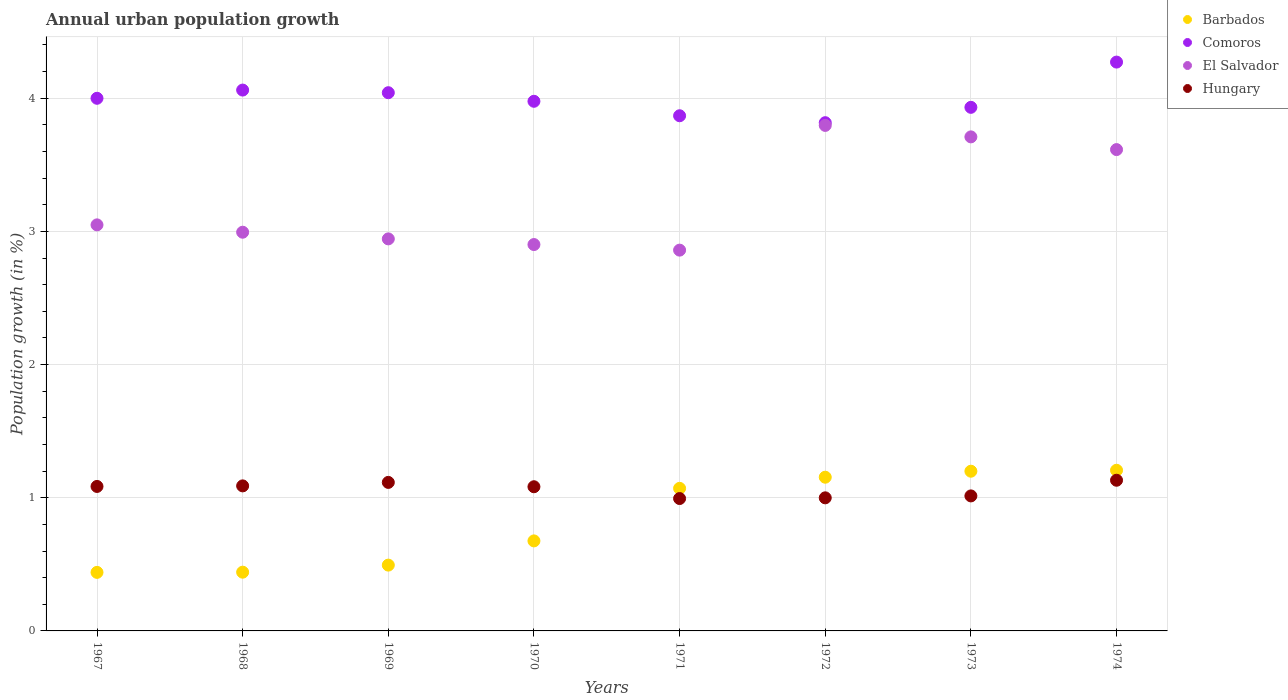How many different coloured dotlines are there?
Make the answer very short. 4. What is the percentage of urban population growth in Hungary in 1973?
Your answer should be compact. 1.01. Across all years, what is the maximum percentage of urban population growth in Barbados?
Your answer should be compact. 1.21. Across all years, what is the minimum percentage of urban population growth in Barbados?
Offer a terse response. 0.44. In which year was the percentage of urban population growth in Hungary maximum?
Offer a very short reply. 1974. In which year was the percentage of urban population growth in El Salvador minimum?
Offer a very short reply. 1971. What is the total percentage of urban population growth in Barbados in the graph?
Your answer should be very brief. 6.68. What is the difference between the percentage of urban population growth in El Salvador in 1968 and that in 1973?
Keep it short and to the point. -0.72. What is the difference between the percentage of urban population growth in Hungary in 1971 and the percentage of urban population growth in El Salvador in 1974?
Provide a succinct answer. -2.62. What is the average percentage of urban population growth in Comoros per year?
Provide a succinct answer. 4. In the year 1967, what is the difference between the percentage of urban population growth in Barbados and percentage of urban population growth in Comoros?
Keep it short and to the point. -3.56. In how many years, is the percentage of urban population growth in Barbados greater than 2.4 %?
Your response must be concise. 0. What is the ratio of the percentage of urban population growth in Hungary in 1967 to that in 1974?
Your answer should be compact. 0.96. Is the percentage of urban population growth in El Salvador in 1969 less than that in 1974?
Make the answer very short. Yes. Is the difference between the percentage of urban population growth in Barbados in 1969 and 1973 greater than the difference between the percentage of urban population growth in Comoros in 1969 and 1973?
Your answer should be very brief. No. What is the difference between the highest and the second highest percentage of urban population growth in Barbados?
Make the answer very short. 0.01. What is the difference between the highest and the lowest percentage of urban population growth in Barbados?
Give a very brief answer. 0.77. Does the percentage of urban population growth in Barbados monotonically increase over the years?
Your answer should be very brief. Yes. Is the percentage of urban population growth in Comoros strictly greater than the percentage of urban population growth in Barbados over the years?
Offer a very short reply. Yes. How many dotlines are there?
Your answer should be very brief. 4. What is the difference between two consecutive major ticks on the Y-axis?
Provide a short and direct response. 1. Are the values on the major ticks of Y-axis written in scientific E-notation?
Provide a succinct answer. No. Does the graph contain grids?
Provide a succinct answer. Yes. Where does the legend appear in the graph?
Keep it short and to the point. Top right. How are the legend labels stacked?
Your response must be concise. Vertical. What is the title of the graph?
Your response must be concise. Annual urban population growth. What is the label or title of the Y-axis?
Your response must be concise. Population growth (in %). What is the Population growth (in %) of Barbados in 1967?
Your answer should be compact. 0.44. What is the Population growth (in %) of Comoros in 1967?
Make the answer very short. 4. What is the Population growth (in %) of El Salvador in 1967?
Ensure brevity in your answer.  3.05. What is the Population growth (in %) in Hungary in 1967?
Your answer should be very brief. 1.08. What is the Population growth (in %) in Barbados in 1968?
Your response must be concise. 0.44. What is the Population growth (in %) of Comoros in 1968?
Give a very brief answer. 4.06. What is the Population growth (in %) of El Salvador in 1968?
Make the answer very short. 2.99. What is the Population growth (in %) in Hungary in 1968?
Your answer should be very brief. 1.09. What is the Population growth (in %) in Barbados in 1969?
Make the answer very short. 0.49. What is the Population growth (in %) of Comoros in 1969?
Offer a terse response. 4.04. What is the Population growth (in %) of El Salvador in 1969?
Offer a terse response. 2.94. What is the Population growth (in %) in Hungary in 1969?
Your answer should be compact. 1.12. What is the Population growth (in %) in Barbados in 1970?
Offer a very short reply. 0.68. What is the Population growth (in %) of Comoros in 1970?
Give a very brief answer. 3.98. What is the Population growth (in %) in El Salvador in 1970?
Provide a short and direct response. 2.9. What is the Population growth (in %) of Hungary in 1970?
Make the answer very short. 1.08. What is the Population growth (in %) in Barbados in 1971?
Provide a succinct answer. 1.07. What is the Population growth (in %) in Comoros in 1971?
Your answer should be very brief. 3.87. What is the Population growth (in %) of El Salvador in 1971?
Offer a very short reply. 2.86. What is the Population growth (in %) of Hungary in 1971?
Your answer should be compact. 0.99. What is the Population growth (in %) in Barbados in 1972?
Make the answer very short. 1.15. What is the Population growth (in %) of Comoros in 1972?
Offer a very short reply. 3.82. What is the Population growth (in %) of El Salvador in 1972?
Provide a short and direct response. 3.8. What is the Population growth (in %) in Hungary in 1972?
Offer a terse response. 1. What is the Population growth (in %) in Barbados in 1973?
Keep it short and to the point. 1.2. What is the Population growth (in %) of Comoros in 1973?
Offer a terse response. 3.93. What is the Population growth (in %) in El Salvador in 1973?
Your answer should be compact. 3.71. What is the Population growth (in %) in Hungary in 1973?
Offer a terse response. 1.01. What is the Population growth (in %) of Barbados in 1974?
Make the answer very short. 1.21. What is the Population growth (in %) of Comoros in 1974?
Give a very brief answer. 4.27. What is the Population growth (in %) in El Salvador in 1974?
Keep it short and to the point. 3.61. What is the Population growth (in %) of Hungary in 1974?
Keep it short and to the point. 1.13. Across all years, what is the maximum Population growth (in %) of Barbados?
Offer a very short reply. 1.21. Across all years, what is the maximum Population growth (in %) of Comoros?
Ensure brevity in your answer.  4.27. Across all years, what is the maximum Population growth (in %) in El Salvador?
Provide a succinct answer. 3.8. Across all years, what is the maximum Population growth (in %) in Hungary?
Offer a terse response. 1.13. Across all years, what is the minimum Population growth (in %) in Barbados?
Ensure brevity in your answer.  0.44. Across all years, what is the minimum Population growth (in %) in Comoros?
Offer a very short reply. 3.82. Across all years, what is the minimum Population growth (in %) of El Salvador?
Offer a very short reply. 2.86. Across all years, what is the minimum Population growth (in %) in Hungary?
Provide a short and direct response. 0.99. What is the total Population growth (in %) in Barbados in the graph?
Provide a short and direct response. 6.68. What is the total Population growth (in %) of Comoros in the graph?
Your answer should be very brief. 31.97. What is the total Population growth (in %) in El Salvador in the graph?
Provide a short and direct response. 25.87. What is the total Population growth (in %) in Hungary in the graph?
Give a very brief answer. 8.51. What is the difference between the Population growth (in %) of Barbados in 1967 and that in 1968?
Make the answer very short. -0. What is the difference between the Population growth (in %) of Comoros in 1967 and that in 1968?
Make the answer very short. -0.06. What is the difference between the Population growth (in %) in El Salvador in 1967 and that in 1968?
Make the answer very short. 0.06. What is the difference between the Population growth (in %) in Hungary in 1967 and that in 1968?
Provide a succinct answer. -0. What is the difference between the Population growth (in %) of Barbados in 1967 and that in 1969?
Give a very brief answer. -0.05. What is the difference between the Population growth (in %) of Comoros in 1967 and that in 1969?
Keep it short and to the point. -0.04. What is the difference between the Population growth (in %) in El Salvador in 1967 and that in 1969?
Provide a short and direct response. 0.11. What is the difference between the Population growth (in %) in Hungary in 1967 and that in 1969?
Provide a succinct answer. -0.03. What is the difference between the Population growth (in %) in Barbados in 1967 and that in 1970?
Offer a very short reply. -0.24. What is the difference between the Population growth (in %) of Comoros in 1967 and that in 1970?
Your response must be concise. 0.02. What is the difference between the Population growth (in %) in El Salvador in 1967 and that in 1970?
Offer a terse response. 0.15. What is the difference between the Population growth (in %) in Hungary in 1967 and that in 1970?
Provide a short and direct response. 0. What is the difference between the Population growth (in %) in Barbados in 1967 and that in 1971?
Provide a short and direct response. -0.63. What is the difference between the Population growth (in %) in Comoros in 1967 and that in 1971?
Provide a short and direct response. 0.13. What is the difference between the Population growth (in %) of El Salvador in 1967 and that in 1971?
Provide a short and direct response. 0.19. What is the difference between the Population growth (in %) of Hungary in 1967 and that in 1971?
Ensure brevity in your answer.  0.09. What is the difference between the Population growth (in %) of Barbados in 1967 and that in 1972?
Give a very brief answer. -0.71. What is the difference between the Population growth (in %) in Comoros in 1967 and that in 1972?
Your answer should be very brief. 0.18. What is the difference between the Population growth (in %) in El Salvador in 1967 and that in 1972?
Your answer should be very brief. -0.75. What is the difference between the Population growth (in %) in Hungary in 1967 and that in 1972?
Offer a very short reply. 0.09. What is the difference between the Population growth (in %) of Barbados in 1967 and that in 1973?
Keep it short and to the point. -0.76. What is the difference between the Population growth (in %) in Comoros in 1967 and that in 1973?
Your answer should be compact. 0.07. What is the difference between the Population growth (in %) in El Salvador in 1967 and that in 1973?
Offer a terse response. -0.66. What is the difference between the Population growth (in %) of Hungary in 1967 and that in 1973?
Make the answer very short. 0.07. What is the difference between the Population growth (in %) in Barbados in 1967 and that in 1974?
Give a very brief answer. -0.77. What is the difference between the Population growth (in %) of Comoros in 1967 and that in 1974?
Make the answer very short. -0.27. What is the difference between the Population growth (in %) in El Salvador in 1967 and that in 1974?
Your answer should be very brief. -0.57. What is the difference between the Population growth (in %) in Hungary in 1967 and that in 1974?
Provide a short and direct response. -0.05. What is the difference between the Population growth (in %) of Barbados in 1968 and that in 1969?
Your answer should be compact. -0.05. What is the difference between the Population growth (in %) of Comoros in 1968 and that in 1969?
Your answer should be very brief. 0.02. What is the difference between the Population growth (in %) in El Salvador in 1968 and that in 1969?
Make the answer very short. 0.05. What is the difference between the Population growth (in %) in Hungary in 1968 and that in 1969?
Offer a terse response. -0.03. What is the difference between the Population growth (in %) in Barbados in 1968 and that in 1970?
Your answer should be very brief. -0.23. What is the difference between the Population growth (in %) in Comoros in 1968 and that in 1970?
Keep it short and to the point. 0.08. What is the difference between the Population growth (in %) of El Salvador in 1968 and that in 1970?
Provide a short and direct response. 0.09. What is the difference between the Population growth (in %) in Hungary in 1968 and that in 1970?
Provide a succinct answer. 0.01. What is the difference between the Population growth (in %) of Barbados in 1968 and that in 1971?
Provide a short and direct response. -0.63. What is the difference between the Population growth (in %) of Comoros in 1968 and that in 1971?
Keep it short and to the point. 0.19. What is the difference between the Population growth (in %) in El Salvador in 1968 and that in 1971?
Offer a very short reply. 0.13. What is the difference between the Population growth (in %) in Hungary in 1968 and that in 1971?
Provide a short and direct response. 0.1. What is the difference between the Population growth (in %) of Barbados in 1968 and that in 1972?
Your answer should be compact. -0.71. What is the difference between the Population growth (in %) of Comoros in 1968 and that in 1972?
Keep it short and to the point. 0.24. What is the difference between the Population growth (in %) in El Salvador in 1968 and that in 1972?
Provide a short and direct response. -0.8. What is the difference between the Population growth (in %) of Hungary in 1968 and that in 1972?
Provide a short and direct response. 0.09. What is the difference between the Population growth (in %) in Barbados in 1968 and that in 1973?
Your answer should be very brief. -0.76. What is the difference between the Population growth (in %) in Comoros in 1968 and that in 1973?
Make the answer very short. 0.13. What is the difference between the Population growth (in %) of El Salvador in 1968 and that in 1973?
Give a very brief answer. -0.72. What is the difference between the Population growth (in %) in Hungary in 1968 and that in 1973?
Make the answer very short. 0.08. What is the difference between the Population growth (in %) of Barbados in 1968 and that in 1974?
Your response must be concise. -0.77. What is the difference between the Population growth (in %) in Comoros in 1968 and that in 1974?
Provide a short and direct response. -0.21. What is the difference between the Population growth (in %) of El Salvador in 1968 and that in 1974?
Keep it short and to the point. -0.62. What is the difference between the Population growth (in %) of Hungary in 1968 and that in 1974?
Ensure brevity in your answer.  -0.04. What is the difference between the Population growth (in %) in Barbados in 1969 and that in 1970?
Your answer should be compact. -0.18. What is the difference between the Population growth (in %) of Comoros in 1969 and that in 1970?
Provide a succinct answer. 0.06. What is the difference between the Population growth (in %) in El Salvador in 1969 and that in 1970?
Offer a terse response. 0.04. What is the difference between the Population growth (in %) in Hungary in 1969 and that in 1970?
Ensure brevity in your answer.  0.03. What is the difference between the Population growth (in %) in Barbados in 1969 and that in 1971?
Provide a succinct answer. -0.58. What is the difference between the Population growth (in %) of Comoros in 1969 and that in 1971?
Ensure brevity in your answer.  0.17. What is the difference between the Population growth (in %) in El Salvador in 1969 and that in 1971?
Your answer should be compact. 0.08. What is the difference between the Population growth (in %) in Hungary in 1969 and that in 1971?
Give a very brief answer. 0.12. What is the difference between the Population growth (in %) in Barbados in 1969 and that in 1972?
Offer a very short reply. -0.66. What is the difference between the Population growth (in %) in Comoros in 1969 and that in 1972?
Your answer should be very brief. 0.23. What is the difference between the Population growth (in %) in El Salvador in 1969 and that in 1972?
Offer a very short reply. -0.85. What is the difference between the Population growth (in %) in Hungary in 1969 and that in 1972?
Keep it short and to the point. 0.12. What is the difference between the Population growth (in %) of Barbados in 1969 and that in 1973?
Provide a short and direct response. -0.7. What is the difference between the Population growth (in %) of Comoros in 1969 and that in 1973?
Give a very brief answer. 0.11. What is the difference between the Population growth (in %) of El Salvador in 1969 and that in 1973?
Your answer should be very brief. -0.77. What is the difference between the Population growth (in %) of Hungary in 1969 and that in 1973?
Your response must be concise. 0.1. What is the difference between the Population growth (in %) of Barbados in 1969 and that in 1974?
Give a very brief answer. -0.71. What is the difference between the Population growth (in %) of Comoros in 1969 and that in 1974?
Offer a very short reply. -0.23. What is the difference between the Population growth (in %) of El Salvador in 1969 and that in 1974?
Your answer should be very brief. -0.67. What is the difference between the Population growth (in %) of Hungary in 1969 and that in 1974?
Keep it short and to the point. -0.02. What is the difference between the Population growth (in %) of Barbados in 1970 and that in 1971?
Provide a succinct answer. -0.39. What is the difference between the Population growth (in %) in Comoros in 1970 and that in 1971?
Offer a very short reply. 0.11. What is the difference between the Population growth (in %) in El Salvador in 1970 and that in 1971?
Provide a short and direct response. 0.04. What is the difference between the Population growth (in %) of Hungary in 1970 and that in 1971?
Offer a very short reply. 0.09. What is the difference between the Population growth (in %) of Barbados in 1970 and that in 1972?
Provide a succinct answer. -0.48. What is the difference between the Population growth (in %) of Comoros in 1970 and that in 1972?
Offer a terse response. 0.16. What is the difference between the Population growth (in %) in El Salvador in 1970 and that in 1972?
Give a very brief answer. -0.89. What is the difference between the Population growth (in %) in Hungary in 1970 and that in 1972?
Your answer should be very brief. 0.08. What is the difference between the Population growth (in %) in Barbados in 1970 and that in 1973?
Your response must be concise. -0.52. What is the difference between the Population growth (in %) of Comoros in 1970 and that in 1973?
Offer a very short reply. 0.05. What is the difference between the Population growth (in %) of El Salvador in 1970 and that in 1973?
Your response must be concise. -0.81. What is the difference between the Population growth (in %) in Hungary in 1970 and that in 1973?
Give a very brief answer. 0.07. What is the difference between the Population growth (in %) of Barbados in 1970 and that in 1974?
Offer a terse response. -0.53. What is the difference between the Population growth (in %) of Comoros in 1970 and that in 1974?
Give a very brief answer. -0.29. What is the difference between the Population growth (in %) in El Salvador in 1970 and that in 1974?
Offer a very short reply. -0.71. What is the difference between the Population growth (in %) in Hungary in 1970 and that in 1974?
Make the answer very short. -0.05. What is the difference between the Population growth (in %) of Barbados in 1971 and that in 1972?
Offer a terse response. -0.08. What is the difference between the Population growth (in %) in Comoros in 1971 and that in 1972?
Ensure brevity in your answer.  0.05. What is the difference between the Population growth (in %) of El Salvador in 1971 and that in 1972?
Give a very brief answer. -0.94. What is the difference between the Population growth (in %) of Hungary in 1971 and that in 1972?
Offer a very short reply. -0.01. What is the difference between the Population growth (in %) of Barbados in 1971 and that in 1973?
Your answer should be very brief. -0.13. What is the difference between the Population growth (in %) in Comoros in 1971 and that in 1973?
Give a very brief answer. -0.06. What is the difference between the Population growth (in %) of El Salvador in 1971 and that in 1973?
Give a very brief answer. -0.85. What is the difference between the Population growth (in %) of Hungary in 1971 and that in 1973?
Make the answer very short. -0.02. What is the difference between the Population growth (in %) in Barbados in 1971 and that in 1974?
Ensure brevity in your answer.  -0.14. What is the difference between the Population growth (in %) of Comoros in 1971 and that in 1974?
Your answer should be compact. -0.4. What is the difference between the Population growth (in %) in El Salvador in 1971 and that in 1974?
Make the answer very short. -0.76. What is the difference between the Population growth (in %) in Hungary in 1971 and that in 1974?
Your answer should be very brief. -0.14. What is the difference between the Population growth (in %) in Barbados in 1972 and that in 1973?
Your response must be concise. -0.04. What is the difference between the Population growth (in %) of Comoros in 1972 and that in 1973?
Keep it short and to the point. -0.12. What is the difference between the Population growth (in %) in El Salvador in 1972 and that in 1973?
Your answer should be compact. 0.09. What is the difference between the Population growth (in %) of Hungary in 1972 and that in 1973?
Provide a short and direct response. -0.01. What is the difference between the Population growth (in %) in Barbados in 1972 and that in 1974?
Give a very brief answer. -0.05. What is the difference between the Population growth (in %) of Comoros in 1972 and that in 1974?
Provide a short and direct response. -0.46. What is the difference between the Population growth (in %) of El Salvador in 1972 and that in 1974?
Keep it short and to the point. 0.18. What is the difference between the Population growth (in %) of Hungary in 1972 and that in 1974?
Make the answer very short. -0.13. What is the difference between the Population growth (in %) in Barbados in 1973 and that in 1974?
Provide a succinct answer. -0.01. What is the difference between the Population growth (in %) of Comoros in 1973 and that in 1974?
Your answer should be compact. -0.34. What is the difference between the Population growth (in %) in El Salvador in 1973 and that in 1974?
Offer a very short reply. 0.1. What is the difference between the Population growth (in %) of Hungary in 1973 and that in 1974?
Your response must be concise. -0.12. What is the difference between the Population growth (in %) of Barbados in 1967 and the Population growth (in %) of Comoros in 1968?
Your response must be concise. -3.62. What is the difference between the Population growth (in %) in Barbados in 1967 and the Population growth (in %) in El Salvador in 1968?
Ensure brevity in your answer.  -2.55. What is the difference between the Population growth (in %) in Barbados in 1967 and the Population growth (in %) in Hungary in 1968?
Your answer should be very brief. -0.65. What is the difference between the Population growth (in %) in Comoros in 1967 and the Population growth (in %) in Hungary in 1968?
Give a very brief answer. 2.91. What is the difference between the Population growth (in %) in El Salvador in 1967 and the Population growth (in %) in Hungary in 1968?
Provide a succinct answer. 1.96. What is the difference between the Population growth (in %) of Barbados in 1967 and the Population growth (in %) of Comoros in 1969?
Offer a very short reply. -3.6. What is the difference between the Population growth (in %) in Barbados in 1967 and the Population growth (in %) in El Salvador in 1969?
Keep it short and to the point. -2.5. What is the difference between the Population growth (in %) of Barbados in 1967 and the Population growth (in %) of Hungary in 1969?
Provide a short and direct response. -0.68. What is the difference between the Population growth (in %) in Comoros in 1967 and the Population growth (in %) in El Salvador in 1969?
Offer a terse response. 1.06. What is the difference between the Population growth (in %) of Comoros in 1967 and the Population growth (in %) of Hungary in 1969?
Your answer should be compact. 2.88. What is the difference between the Population growth (in %) of El Salvador in 1967 and the Population growth (in %) of Hungary in 1969?
Offer a terse response. 1.93. What is the difference between the Population growth (in %) in Barbados in 1967 and the Population growth (in %) in Comoros in 1970?
Offer a very short reply. -3.54. What is the difference between the Population growth (in %) of Barbados in 1967 and the Population growth (in %) of El Salvador in 1970?
Keep it short and to the point. -2.46. What is the difference between the Population growth (in %) of Barbados in 1967 and the Population growth (in %) of Hungary in 1970?
Offer a terse response. -0.64. What is the difference between the Population growth (in %) of Comoros in 1967 and the Population growth (in %) of El Salvador in 1970?
Your response must be concise. 1.1. What is the difference between the Population growth (in %) of Comoros in 1967 and the Population growth (in %) of Hungary in 1970?
Your answer should be very brief. 2.92. What is the difference between the Population growth (in %) of El Salvador in 1967 and the Population growth (in %) of Hungary in 1970?
Your answer should be very brief. 1.97. What is the difference between the Population growth (in %) of Barbados in 1967 and the Population growth (in %) of Comoros in 1971?
Make the answer very short. -3.43. What is the difference between the Population growth (in %) in Barbados in 1967 and the Population growth (in %) in El Salvador in 1971?
Ensure brevity in your answer.  -2.42. What is the difference between the Population growth (in %) of Barbados in 1967 and the Population growth (in %) of Hungary in 1971?
Keep it short and to the point. -0.55. What is the difference between the Population growth (in %) in Comoros in 1967 and the Population growth (in %) in El Salvador in 1971?
Your answer should be compact. 1.14. What is the difference between the Population growth (in %) in Comoros in 1967 and the Population growth (in %) in Hungary in 1971?
Offer a terse response. 3.01. What is the difference between the Population growth (in %) in El Salvador in 1967 and the Population growth (in %) in Hungary in 1971?
Make the answer very short. 2.05. What is the difference between the Population growth (in %) of Barbados in 1967 and the Population growth (in %) of Comoros in 1972?
Offer a terse response. -3.38. What is the difference between the Population growth (in %) in Barbados in 1967 and the Population growth (in %) in El Salvador in 1972?
Provide a short and direct response. -3.36. What is the difference between the Population growth (in %) in Barbados in 1967 and the Population growth (in %) in Hungary in 1972?
Offer a terse response. -0.56. What is the difference between the Population growth (in %) in Comoros in 1967 and the Population growth (in %) in El Salvador in 1972?
Your answer should be compact. 0.2. What is the difference between the Population growth (in %) of Comoros in 1967 and the Population growth (in %) of Hungary in 1972?
Offer a very short reply. 3. What is the difference between the Population growth (in %) in El Salvador in 1967 and the Population growth (in %) in Hungary in 1972?
Offer a terse response. 2.05. What is the difference between the Population growth (in %) of Barbados in 1967 and the Population growth (in %) of Comoros in 1973?
Ensure brevity in your answer.  -3.49. What is the difference between the Population growth (in %) in Barbados in 1967 and the Population growth (in %) in El Salvador in 1973?
Keep it short and to the point. -3.27. What is the difference between the Population growth (in %) of Barbados in 1967 and the Population growth (in %) of Hungary in 1973?
Your response must be concise. -0.57. What is the difference between the Population growth (in %) in Comoros in 1967 and the Population growth (in %) in El Salvador in 1973?
Offer a terse response. 0.29. What is the difference between the Population growth (in %) in Comoros in 1967 and the Population growth (in %) in Hungary in 1973?
Your answer should be very brief. 2.99. What is the difference between the Population growth (in %) in El Salvador in 1967 and the Population growth (in %) in Hungary in 1973?
Offer a terse response. 2.04. What is the difference between the Population growth (in %) of Barbados in 1967 and the Population growth (in %) of Comoros in 1974?
Your answer should be very brief. -3.83. What is the difference between the Population growth (in %) in Barbados in 1967 and the Population growth (in %) in El Salvador in 1974?
Make the answer very short. -3.17. What is the difference between the Population growth (in %) in Barbados in 1967 and the Population growth (in %) in Hungary in 1974?
Your answer should be very brief. -0.69. What is the difference between the Population growth (in %) of Comoros in 1967 and the Population growth (in %) of El Salvador in 1974?
Provide a short and direct response. 0.39. What is the difference between the Population growth (in %) of Comoros in 1967 and the Population growth (in %) of Hungary in 1974?
Your answer should be compact. 2.87. What is the difference between the Population growth (in %) in El Salvador in 1967 and the Population growth (in %) in Hungary in 1974?
Give a very brief answer. 1.92. What is the difference between the Population growth (in %) of Barbados in 1968 and the Population growth (in %) of Comoros in 1969?
Provide a short and direct response. -3.6. What is the difference between the Population growth (in %) in Barbados in 1968 and the Population growth (in %) in El Salvador in 1969?
Make the answer very short. -2.5. What is the difference between the Population growth (in %) in Barbados in 1968 and the Population growth (in %) in Hungary in 1969?
Provide a succinct answer. -0.67. What is the difference between the Population growth (in %) of Comoros in 1968 and the Population growth (in %) of El Salvador in 1969?
Provide a succinct answer. 1.12. What is the difference between the Population growth (in %) of Comoros in 1968 and the Population growth (in %) of Hungary in 1969?
Provide a succinct answer. 2.95. What is the difference between the Population growth (in %) of El Salvador in 1968 and the Population growth (in %) of Hungary in 1969?
Give a very brief answer. 1.88. What is the difference between the Population growth (in %) in Barbados in 1968 and the Population growth (in %) in Comoros in 1970?
Give a very brief answer. -3.54. What is the difference between the Population growth (in %) in Barbados in 1968 and the Population growth (in %) in El Salvador in 1970?
Offer a terse response. -2.46. What is the difference between the Population growth (in %) in Barbados in 1968 and the Population growth (in %) in Hungary in 1970?
Provide a succinct answer. -0.64. What is the difference between the Population growth (in %) in Comoros in 1968 and the Population growth (in %) in El Salvador in 1970?
Make the answer very short. 1.16. What is the difference between the Population growth (in %) of Comoros in 1968 and the Population growth (in %) of Hungary in 1970?
Give a very brief answer. 2.98. What is the difference between the Population growth (in %) in El Salvador in 1968 and the Population growth (in %) in Hungary in 1970?
Offer a terse response. 1.91. What is the difference between the Population growth (in %) in Barbados in 1968 and the Population growth (in %) in Comoros in 1971?
Offer a very short reply. -3.43. What is the difference between the Population growth (in %) in Barbados in 1968 and the Population growth (in %) in El Salvador in 1971?
Offer a very short reply. -2.42. What is the difference between the Population growth (in %) in Barbados in 1968 and the Population growth (in %) in Hungary in 1971?
Your response must be concise. -0.55. What is the difference between the Population growth (in %) in Comoros in 1968 and the Population growth (in %) in El Salvador in 1971?
Give a very brief answer. 1.2. What is the difference between the Population growth (in %) of Comoros in 1968 and the Population growth (in %) of Hungary in 1971?
Provide a succinct answer. 3.07. What is the difference between the Population growth (in %) in El Salvador in 1968 and the Population growth (in %) in Hungary in 1971?
Your answer should be compact. 2. What is the difference between the Population growth (in %) in Barbados in 1968 and the Population growth (in %) in Comoros in 1972?
Keep it short and to the point. -3.38. What is the difference between the Population growth (in %) of Barbados in 1968 and the Population growth (in %) of El Salvador in 1972?
Ensure brevity in your answer.  -3.35. What is the difference between the Population growth (in %) in Barbados in 1968 and the Population growth (in %) in Hungary in 1972?
Your response must be concise. -0.56. What is the difference between the Population growth (in %) of Comoros in 1968 and the Population growth (in %) of El Salvador in 1972?
Provide a short and direct response. 0.27. What is the difference between the Population growth (in %) of Comoros in 1968 and the Population growth (in %) of Hungary in 1972?
Make the answer very short. 3.06. What is the difference between the Population growth (in %) in El Salvador in 1968 and the Population growth (in %) in Hungary in 1972?
Offer a very short reply. 1.99. What is the difference between the Population growth (in %) of Barbados in 1968 and the Population growth (in %) of Comoros in 1973?
Offer a terse response. -3.49. What is the difference between the Population growth (in %) in Barbados in 1968 and the Population growth (in %) in El Salvador in 1973?
Your answer should be compact. -3.27. What is the difference between the Population growth (in %) in Barbados in 1968 and the Population growth (in %) in Hungary in 1973?
Make the answer very short. -0.57. What is the difference between the Population growth (in %) in Comoros in 1968 and the Population growth (in %) in El Salvador in 1973?
Ensure brevity in your answer.  0.35. What is the difference between the Population growth (in %) of Comoros in 1968 and the Population growth (in %) of Hungary in 1973?
Offer a terse response. 3.05. What is the difference between the Population growth (in %) in El Salvador in 1968 and the Population growth (in %) in Hungary in 1973?
Give a very brief answer. 1.98. What is the difference between the Population growth (in %) in Barbados in 1968 and the Population growth (in %) in Comoros in 1974?
Offer a very short reply. -3.83. What is the difference between the Population growth (in %) in Barbados in 1968 and the Population growth (in %) in El Salvador in 1974?
Your answer should be very brief. -3.17. What is the difference between the Population growth (in %) of Barbados in 1968 and the Population growth (in %) of Hungary in 1974?
Your answer should be very brief. -0.69. What is the difference between the Population growth (in %) in Comoros in 1968 and the Population growth (in %) in El Salvador in 1974?
Offer a very short reply. 0.45. What is the difference between the Population growth (in %) in Comoros in 1968 and the Population growth (in %) in Hungary in 1974?
Offer a very short reply. 2.93. What is the difference between the Population growth (in %) of El Salvador in 1968 and the Population growth (in %) of Hungary in 1974?
Your answer should be very brief. 1.86. What is the difference between the Population growth (in %) of Barbados in 1969 and the Population growth (in %) of Comoros in 1970?
Give a very brief answer. -3.48. What is the difference between the Population growth (in %) in Barbados in 1969 and the Population growth (in %) in El Salvador in 1970?
Make the answer very short. -2.41. What is the difference between the Population growth (in %) of Barbados in 1969 and the Population growth (in %) of Hungary in 1970?
Provide a short and direct response. -0.59. What is the difference between the Population growth (in %) of Comoros in 1969 and the Population growth (in %) of El Salvador in 1970?
Make the answer very short. 1.14. What is the difference between the Population growth (in %) in Comoros in 1969 and the Population growth (in %) in Hungary in 1970?
Give a very brief answer. 2.96. What is the difference between the Population growth (in %) in El Salvador in 1969 and the Population growth (in %) in Hungary in 1970?
Keep it short and to the point. 1.86. What is the difference between the Population growth (in %) of Barbados in 1969 and the Population growth (in %) of Comoros in 1971?
Give a very brief answer. -3.37. What is the difference between the Population growth (in %) in Barbados in 1969 and the Population growth (in %) in El Salvador in 1971?
Provide a succinct answer. -2.37. What is the difference between the Population growth (in %) in Barbados in 1969 and the Population growth (in %) in Hungary in 1971?
Offer a very short reply. -0.5. What is the difference between the Population growth (in %) in Comoros in 1969 and the Population growth (in %) in El Salvador in 1971?
Provide a short and direct response. 1.18. What is the difference between the Population growth (in %) of Comoros in 1969 and the Population growth (in %) of Hungary in 1971?
Give a very brief answer. 3.05. What is the difference between the Population growth (in %) of El Salvador in 1969 and the Population growth (in %) of Hungary in 1971?
Offer a very short reply. 1.95. What is the difference between the Population growth (in %) of Barbados in 1969 and the Population growth (in %) of Comoros in 1972?
Provide a short and direct response. -3.32. What is the difference between the Population growth (in %) in Barbados in 1969 and the Population growth (in %) in El Salvador in 1972?
Ensure brevity in your answer.  -3.3. What is the difference between the Population growth (in %) in Barbados in 1969 and the Population growth (in %) in Hungary in 1972?
Ensure brevity in your answer.  -0.51. What is the difference between the Population growth (in %) in Comoros in 1969 and the Population growth (in %) in El Salvador in 1972?
Your answer should be compact. 0.25. What is the difference between the Population growth (in %) of Comoros in 1969 and the Population growth (in %) of Hungary in 1972?
Your answer should be compact. 3.04. What is the difference between the Population growth (in %) in El Salvador in 1969 and the Population growth (in %) in Hungary in 1972?
Offer a very short reply. 1.94. What is the difference between the Population growth (in %) in Barbados in 1969 and the Population growth (in %) in Comoros in 1973?
Provide a succinct answer. -3.44. What is the difference between the Population growth (in %) in Barbados in 1969 and the Population growth (in %) in El Salvador in 1973?
Provide a short and direct response. -3.22. What is the difference between the Population growth (in %) of Barbados in 1969 and the Population growth (in %) of Hungary in 1973?
Make the answer very short. -0.52. What is the difference between the Population growth (in %) of Comoros in 1969 and the Population growth (in %) of El Salvador in 1973?
Provide a succinct answer. 0.33. What is the difference between the Population growth (in %) in Comoros in 1969 and the Population growth (in %) in Hungary in 1973?
Give a very brief answer. 3.03. What is the difference between the Population growth (in %) in El Salvador in 1969 and the Population growth (in %) in Hungary in 1973?
Your answer should be very brief. 1.93. What is the difference between the Population growth (in %) of Barbados in 1969 and the Population growth (in %) of Comoros in 1974?
Provide a short and direct response. -3.78. What is the difference between the Population growth (in %) in Barbados in 1969 and the Population growth (in %) in El Salvador in 1974?
Give a very brief answer. -3.12. What is the difference between the Population growth (in %) of Barbados in 1969 and the Population growth (in %) of Hungary in 1974?
Make the answer very short. -0.64. What is the difference between the Population growth (in %) in Comoros in 1969 and the Population growth (in %) in El Salvador in 1974?
Make the answer very short. 0.43. What is the difference between the Population growth (in %) of Comoros in 1969 and the Population growth (in %) of Hungary in 1974?
Offer a very short reply. 2.91. What is the difference between the Population growth (in %) in El Salvador in 1969 and the Population growth (in %) in Hungary in 1974?
Your response must be concise. 1.81. What is the difference between the Population growth (in %) in Barbados in 1970 and the Population growth (in %) in Comoros in 1971?
Keep it short and to the point. -3.19. What is the difference between the Population growth (in %) in Barbados in 1970 and the Population growth (in %) in El Salvador in 1971?
Your response must be concise. -2.18. What is the difference between the Population growth (in %) in Barbados in 1970 and the Population growth (in %) in Hungary in 1971?
Your answer should be very brief. -0.32. What is the difference between the Population growth (in %) in Comoros in 1970 and the Population growth (in %) in El Salvador in 1971?
Offer a terse response. 1.12. What is the difference between the Population growth (in %) of Comoros in 1970 and the Population growth (in %) of Hungary in 1971?
Ensure brevity in your answer.  2.98. What is the difference between the Population growth (in %) in El Salvador in 1970 and the Population growth (in %) in Hungary in 1971?
Your answer should be compact. 1.91. What is the difference between the Population growth (in %) in Barbados in 1970 and the Population growth (in %) in Comoros in 1972?
Ensure brevity in your answer.  -3.14. What is the difference between the Population growth (in %) of Barbados in 1970 and the Population growth (in %) of El Salvador in 1972?
Your response must be concise. -3.12. What is the difference between the Population growth (in %) of Barbados in 1970 and the Population growth (in %) of Hungary in 1972?
Your response must be concise. -0.32. What is the difference between the Population growth (in %) of Comoros in 1970 and the Population growth (in %) of El Salvador in 1972?
Make the answer very short. 0.18. What is the difference between the Population growth (in %) in Comoros in 1970 and the Population growth (in %) in Hungary in 1972?
Give a very brief answer. 2.98. What is the difference between the Population growth (in %) in El Salvador in 1970 and the Population growth (in %) in Hungary in 1972?
Your answer should be compact. 1.9. What is the difference between the Population growth (in %) in Barbados in 1970 and the Population growth (in %) in Comoros in 1973?
Provide a succinct answer. -3.26. What is the difference between the Population growth (in %) in Barbados in 1970 and the Population growth (in %) in El Salvador in 1973?
Make the answer very short. -3.03. What is the difference between the Population growth (in %) of Barbados in 1970 and the Population growth (in %) of Hungary in 1973?
Offer a terse response. -0.34. What is the difference between the Population growth (in %) of Comoros in 1970 and the Population growth (in %) of El Salvador in 1973?
Your answer should be very brief. 0.27. What is the difference between the Population growth (in %) of Comoros in 1970 and the Population growth (in %) of Hungary in 1973?
Your answer should be very brief. 2.96. What is the difference between the Population growth (in %) in El Salvador in 1970 and the Population growth (in %) in Hungary in 1973?
Offer a very short reply. 1.89. What is the difference between the Population growth (in %) of Barbados in 1970 and the Population growth (in %) of Comoros in 1974?
Provide a short and direct response. -3.6. What is the difference between the Population growth (in %) of Barbados in 1970 and the Population growth (in %) of El Salvador in 1974?
Ensure brevity in your answer.  -2.94. What is the difference between the Population growth (in %) of Barbados in 1970 and the Population growth (in %) of Hungary in 1974?
Make the answer very short. -0.46. What is the difference between the Population growth (in %) of Comoros in 1970 and the Population growth (in %) of El Salvador in 1974?
Offer a terse response. 0.36. What is the difference between the Population growth (in %) in Comoros in 1970 and the Population growth (in %) in Hungary in 1974?
Your response must be concise. 2.85. What is the difference between the Population growth (in %) of El Salvador in 1970 and the Population growth (in %) of Hungary in 1974?
Your answer should be very brief. 1.77. What is the difference between the Population growth (in %) of Barbados in 1971 and the Population growth (in %) of Comoros in 1972?
Your answer should be very brief. -2.75. What is the difference between the Population growth (in %) in Barbados in 1971 and the Population growth (in %) in El Salvador in 1972?
Keep it short and to the point. -2.73. What is the difference between the Population growth (in %) of Barbados in 1971 and the Population growth (in %) of Hungary in 1972?
Ensure brevity in your answer.  0.07. What is the difference between the Population growth (in %) in Comoros in 1971 and the Population growth (in %) in El Salvador in 1972?
Give a very brief answer. 0.07. What is the difference between the Population growth (in %) of Comoros in 1971 and the Population growth (in %) of Hungary in 1972?
Offer a very short reply. 2.87. What is the difference between the Population growth (in %) of El Salvador in 1971 and the Population growth (in %) of Hungary in 1972?
Keep it short and to the point. 1.86. What is the difference between the Population growth (in %) of Barbados in 1971 and the Population growth (in %) of Comoros in 1973?
Provide a short and direct response. -2.86. What is the difference between the Population growth (in %) of Barbados in 1971 and the Population growth (in %) of El Salvador in 1973?
Your answer should be very brief. -2.64. What is the difference between the Population growth (in %) in Barbados in 1971 and the Population growth (in %) in Hungary in 1973?
Keep it short and to the point. 0.06. What is the difference between the Population growth (in %) of Comoros in 1971 and the Population growth (in %) of El Salvador in 1973?
Your answer should be very brief. 0.16. What is the difference between the Population growth (in %) in Comoros in 1971 and the Population growth (in %) in Hungary in 1973?
Offer a very short reply. 2.85. What is the difference between the Population growth (in %) of El Salvador in 1971 and the Population growth (in %) of Hungary in 1973?
Your answer should be very brief. 1.85. What is the difference between the Population growth (in %) in Barbados in 1971 and the Population growth (in %) in Comoros in 1974?
Offer a very short reply. -3.2. What is the difference between the Population growth (in %) in Barbados in 1971 and the Population growth (in %) in El Salvador in 1974?
Keep it short and to the point. -2.54. What is the difference between the Population growth (in %) of Barbados in 1971 and the Population growth (in %) of Hungary in 1974?
Your answer should be very brief. -0.06. What is the difference between the Population growth (in %) of Comoros in 1971 and the Population growth (in %) of El Salvador in 1974?
Provide a succinct answer. 0.25. What is the difference between the Population growth (in %) in Comoros in 1971 and the Population growth (in %) in Hungary in 1974?
Make the answer very short. 2.74. What is the difference between the Population growth (in %) of El Salvador in 1971 and the Population growth (in %) of Hungary in 1974?
Offer a very short reply. 1.73. What is the difference between the Population growth (in %) of Barbados in 1972 and the Population growth (in %) of Comoros in 1973?
Your answer should be compact. -2.78. What is the difference between the Population growth (in %) of Barbados in 1972 and the Population growth (in %) of El Salvador in 1973?
Offer a very short reply. -2.56. What is the difference between the Population growth (in %) of Barbados in 1972 and the Population growth (in %) of Hungary in 1973?
Offer a very short reply. 0.14. What is the difference between the Population growth (in %) in Comoros in 1972 and the Population growth (in %) in El Salvador in 1973?
Make the answer very short. 0.11. What is the difference between the Population growth (in %) in Comoros in 1972 and the Population growth (in %) in Hungary in 1973?
Make the answer very short. 2.8. What is the difference between the Population growth (in %) of El Salvador in 1972 and the Population growth (in %) of Hungary in 1973?
Provide a short and direct response. 2.78. What is the difference between the Population growth (in %) in Barbados in 1972 and the Population growth (in %) in Comoros in 1974?
Keep it short and to the point. -3.12. What is the difference between the Population growth (in %) in Barbados in 1972 and the Population growth (in %) in El Salvador in 1974?
Ensure brevity in your answer.  -2.46. What is the difference between the Population growth (in %) in Barbados in 1972 and the Population growth (in %) in Hungary in 1974?
Provide a succinct answer. 0.02. What is the difference between the Population growth (in %) of Comoros in 1972 and the Population growth (in %) of El Salvador in 1974?
Make the answer very short. 0.2. What is the difference between the Population growth (in %) of Comoros in 1972 and the Population growth (in %) of Hungary in 1974?
Make the answer very short. 2.68. What is the difference between the Population growth (in %) of El Salvador in 1972 and the Population growth (in %) of Hungary in 1974?
Provide a short and direct response. 2.66. What is the difference between the Population growth (in %) in Barbados in 1973 and the Population growth (in %) in Comoros in 1974?
Offer a very short reply. -3.07. What is the difference between the Population growth (in %) in Barbados in 1973 and the Population growth (in %) in El Salvador in 1974?
Your response must be concise. -2.42. What is the difference between the Population growth (in %) in Barbados in 1973 and the Population growth (in %) in Hungary in 1974?
Ensure brevity in your answer.  0.07. What is the difference between the Population growth (in %) of Comoros in 1973 and the Population growth (in %) of El Salvador in 1974?
Your response must be concise. 0.32. What is the difference between the Population growth (in %) of Comoros in 1973 and the Population growth (in %) of Hungary in 1974?
Your response must be concise. 2.8. What is the difference between the Population growth (in %) in El Salvador in 1973 and the Population growth (in %) in Hungary in 1974?
Your response must be concise. 2.58. What is the average Population growth (in %) in Barbados per year?
Keep it short and to the point. 0.84. What is the average Population growth (in %) of Comoros per year?
Keep it short and to the point. 4. What is the average Population growth (in %) of El Salvador per year?
Your answer should be very brief. 3.23. What is the average Population growth (in %) of Hungary per year?
Make the answer very short. 1.06. In the year 1967, what is the difference between the Population growth (in %) of Barbados and Population growth (in %) of Comoros?
Provide a succinct answer. -3.56. In the year 1967, what is the difference between the Population growth (in %) of Barbados and Population growth (in %) of El Salvador?
Keep it short and to the point. -2.61. In the year 1967, what is the difference between the Population growth (in %) in Barbados and Population growth (in %) in Hungary?
Give a very brief answer. -0.65. In the year 1967, what is the difference between the Population growth (in %) of Comoros and Population growth (in %) of El Salvador?
Ensure brevity in your answer.  0.95. In the year 1967, what is the difference between the Population growth (in %) of Comoros and Population growth (in %) of Hungary?
Give a very brief answer. 2.91. In the year 1967, what is the difference between the Population growth (in %) in El Salvador and Population growth (in %) in Hungary?
Give a very brief answer. 1.96. In the year 1968, what is the difference between the Population growth (in %) in Barbados and Population growth (in %) in Comoros?
Make the answer very short. -3.62. In the year 1968, what is the difference between the Population growth (in %) in Barbados and Population growth (in %) in El Salvador?
Offer a terse response. -2.55. In the year 1968, what is the difference between the Population growth (in %) in Barbados and Population growth (in %) in Hungary?
Provide a short and direct response. -0.65. In the year 1968, what is the difference between the Population growth (in %) of Comoros and Population growth (in %) of El Salvador?
Ensure brevity in your answer.  1.07. In the year 1968, what is the difference between the Population growth (in %) of Comoros and Population growth (in %) of Hungary?
Your answer should be very brief. 2.97. In the year 1968, what is the difference between the Population growth (in %) in El Salvador and Population growth (in %) in Hungary?
Offer a very short reply. 1.9. In the year 1969, what is the difference between the Population growth (in %) in Barbados and Population growth (in %) in Comoros?
Offer a terse response. -3.55. In the year 1969, what is the difference between the Population growth (in %) of Barbados and Population growth (in %) of El Salvador?
Offer a very short reply. -2.45. In the year 1969, what is the difference between the Population growth (in %) of Barbados and Population growth (in %) of Hungary?
Provide a succinct answer. -0.62. In the year 1969, what is the difference between the Population growth (in %) in Comoros and Population growth (in %) in El Salvador?
Ensure brevity in your answer.  1.1. In the year 1969, what is the difference between the Population growth (in %) of Comoros and Population growth (in %) of Hungary?
Provide a short and direct response. 2.93. In the year 1969, what is the difference between the Population growth (in %) of El Salvador and Population growth (in %) of Hungary?
Give a very brief answer. 1.83. In the year 1970, what is the difference between the Population growth (in %) of Barbados and Population growth (in %) of Comoros?
Keep it short and to the point. -3.3. In the year 1970, what is the difference between the Population growth (in %) in Barbados and Population growth (in %) in El Salvador?
Make the answer very short. -2.23. In the year 1970, what is the difference between the Population growth (in %) of Barbados and Population growth (in %) of Hungary?
Offer a very short reply. -0.41. In the year 1970, what is the difference between the Population growth (in %) of Comoros and Population growth (in %) of El Salvador?
Your answer should be compact. 1.08. In the year 1970, what is the difference between the Population growth (in %) in Comoros and Population growth (in %) in Hungary?
Keep it short and to the point. 2.89. In the year 1970, what is the difference between the Population growth (in %) in El Salvador and Population growth (in %) in Hungary?
Offer a very short reply. 1.82. In the year 1971, what is the difference between the Population growth (in %) of Barbados and Population growth (in %) of Comoros?
Keep it short and to the point. -2.8. In the year 1971, what is the difference between the Population growth (in %) in Barbados and Population growth (in %) in El Salvador?
Your answer should be very brief. -1.79. In the year 1971, what is the difference between the Population growth (in %) of Barbados and Population growth (in %) of Hungary?
Make the answer very short. 0.08. In the year 1971, what is the difference between the Population growth (in %) in Comoros and Population growth (in %) in El Salvador?
Give a very brief answer. 1.01. In the year 1971, what is the difference between the Population growth (in %) of Comoros and Population growth (in %) of Hungary?
Offer a terse response. 2.87. In the year 1971, what is the difference between the Population growth (in %) in El Salvador and Population growth (in %) in Hungary?
Your answer should be very brief. 1.87. In the year 1972, what is the difference between the Population growth (in %) in Barbados and Population growth (in %) in Comoros?
Provide a succinct answer. -2.66. In the year 1972, what is the difference between the Population growth (in %) in Barbados and Population growth (in %) in El Salvador?
Make the answer very short. -2.64. In the year 1972, what is the difference between the Population growth (in %) in Barbados and Population growth (in %) in Hungary?
Provide a succinct answer. 0.15. In the year 1972, what is the difference between the Population growth (in %) in Comoros and Population growth (in %) in El Salvador?
Provide a short and direct response. 0.02. In the year 1972, what is the difference between the Population growth (in %) of Comoros and Population growth (in %) of Hungary?
Your answer should be compact. 2.82. In the year 1972, what is the difference between the Population growth (in %) in El Salvador and Population growth (in %) in Hungary?
Your response must be concise. 2.8. In the year 1973, what is the difference between the Population growth (in %) of Barbados and Population growth (in %) of Comoros?
Make the answer very short. -2.73. In the year 1973, what is the difference between the Population growth (in %) of Barbados and Population growth (in %) of El Salvador?
Your answer should be very brief. -2.51. In the year 1973, what is the difference between the Population growth (in %) of Barbados and Population growth (in %) of Hungary?
Make the answer very short. 0.19. In the year 1973, what is the difference between the Population growth (in %) of Comoros and Population growth (in %) of El Salvador?
Make the answer very short. 0.22. In the year 1973, what is the difference between the Population growth (in %) of Comoros and Population growth (in %) of Hungary?
Ensure brevity in your answer.  2.92. In the year 1973, what is the difference between the Population growth (in %) in El Salvador and Population growth (in %) in Hungary?
Your answer should be very brief. 2.7. In the year 1974, what is the difference between the Population growth (in %) of Barbados and Population growth (in %) of Comoros?
Give a very brief answer. -3.06. In the year 1974, what is the difference between the Population growth (in %) of Barbados and Population growth (in %) of El Salvador?
Keep it short and to the point. -2.41. In the year 1974, what is the difference between the Population growth (in %) of Barbados and Population growth (in %) of Hungary?
Your answer should be compact. 0.07. In the year 1974, what is the difference between the Population growth (in %) of Comoros and Population growth (in %) of El Salvador?
Offer a terse response. 0.66. In the year 1974, what is the difference between the Population growth (in %) of Comoros and Population growth (in %) of Hungary?
Ensure brevity in your answer.  3.14. In the year 1974, what is the difference between the Population growth (in %) of El Salvador and Population growth (in %) of Hungary?
Give a very brief answer. 2.48. What is the ratio of the Population growth (in %) of Comoros in 1967 to that in 1968?
Offer a terse response. 0.98. What is the ratio of the Population growth (in %) in El Salvador in 1967 to that in 1968?
Make the answer very short. 1.02. What is the ratio of the Population growth (in %) of Barbados in 1967 to that in 1969?
Offer a terse response. 0.89. What is the ratio of the Population growth (in %) of Comoros in 1967 to that in 1969?
Give a very brief answer. 0.99. What is the ratio of the Population growth (in %) in El Salvador in 1967 to that in 1969?
Provide a short and direct response. 1.04. What is the ratio of the Population growth (in %) in Hungary in 1967 to that in 1969?
Ensure brevity in your answer.  0.97. What is the ratio of the Population growth (in %) of Barbados in 1967 to that in 1970?
Keep it short and to the point. 0.65. What is the ratio of the Population growth (in %) of Comoros in 1967 to that in 1970?
Offer a very short reply. 1.01. What is the ratio of the Population growth (in %) in El Salvador in 1967 to that in 1970?
Offer a very short reply. 1.05. What is the ratio of the Population growth (in %) in Barbados in 1967 to that in 1971?
Your response must be concise. 0.41. What is the ratio of the Population growth (in %) in Comoros in 1967 to that in 1971?
Your answer should be compact. 1.03. What is the ratio of the Population growth (in %) of El Salvador in 1967 to that in 1971?
Offer a terse response. 1.07. What is the ratio of the Population growth (in %) of Hungary in 1967 to that in 1971?
Keep it short and to the point. 1.09. What is the ratio of the Population growth (in %) of Barbados in 1967 to that in 1972?
Provide a succinct answer. 0.38. What is the ratio of the Population growth (in %) in Comoros in 1967 to that in 1972?
Offer a very short reply. 1.05. What is the ratio of the Population growth (in %) in El Salvador in 1967 to that in 1972?
Your answer should be very brief. 0.8. What is the ratio of the Population growth (in %) of Hungary in 1967 to that in 1972?
Your response must be concise. 1.09. What is the ratio of the Population growth (in %) of Barbados in 1967 to that in 1973?
Offer a very short reply. 0.37. What is the ratio of the Population growth (in %) of Comoros in 1967 to that in 1973?
Offer a very short reply. 1.02. What is the ratio of the Population growth (in %) in El Salvador in 1967 to that in 1973?
Keep it short and to the point. 0.82. What is the ratio of the Population growth (in %) in Hungary in 1967 to that in 1973?
Ensure brevity in your answer.  1.07. What is the ratio of the Population growth (in %) of Barbados in 1967 to that in 1974?
Ensure brevity in your answer.  0.36. What is the ratio of the Population growth (in %) of Comoros in 1967 to that in 1974?
Provide a short and direct response. 0.94. What is the ratio of the Population growth (in %) of El Salvador in 1967 to that in 1974?
Your response must be concise. 0.84. What is the ratio of the Population growth (in %) in Hungary in 1967 to that in 1974?
Provide a succinct answer. 0.96. What is the ratio of the Population growth (in %) in Barbados in 1968 to that in 1969?
Provide a succinct answer. 0.89. What is the ratio of the Population growth (in %) in Comoros in 1968 to that in 1969?
Make the answer very short. 1. What is the ratio of the Population growth (in %) in El Salvador in 1968 to that in 1969?
Your response must be concise. 1.02. What is the ratio of the Population growth (in %) in Hungary in 1968 to that in 1969?
Your answer should be very brief. 0.98. What is the ratio of the Population growth (in %) in Barbados in 1968 to that in 1970?
Your response must be concise. 0.65. What is the ratio of the Population growth (in %) of Comoros in 1968 to that in 1970?
Provide a short and direct response. 1.02. What is the ratio of the Population growth (in %) of El Salvador in 1968 to that in 1970?
Provide a short and direct response. 1.03. What is the ratio of the Population growth (in %) of Hungary in 1968 to that in 1970?
Keep it short and to the point. 1.01. What is the ratio of the Population growth (in %) in Barbados in 1968 to that in 1971?
Keep it short and to the point. 0.41. What is the ratio of the Population growth (in %) in Comoros in 1968 to that in 1971?
Provide a short and direct response. 1.05. What is the ratio of the Population growth (in %) of El Salvador in 1968 to that in 1971?
Make the answer very short. 1.05. What is the ratio of the Population growth (in %) of Hungary in 1968 to that in 1971?
Give a very brief answer. 1.1. What is the ratio of the Population growth (in %) in Barbados in 1968 to that in 1972?
Offer a very short reply. 0.38. What is the ratio of the Population growth (in %) in Comoros in 1968 to that in 1972?
Your response must be concise. 1.06. What is the ratio of the Population growth (in %) of El Salvador in 1968 to that in 1972?
Your response must be concise. 0.79. What is the ratio of the Population growth (in %) of Hungary in 1968 to that in 1972?
Offer a very short reply. 1.09. What is the ratio of the Population growth (in %) in Barbados in 1968 to that in 1973?
Provide a succinct answer. 0.37. What is the ratio of the Population growth (in %) in Comoros in 1968 to that in 1973?
Make the answer very short. 1.03. What is the ratio of the Population growth (in %) in El Salvador in 1968 to that in 1973?
Offer a very short reply. 0.81. What is the ratio of the Population growth (in %) of Hungary in 1968 to that in 1973?
Keep it short and to the point. 1.07. What is the ratio of the Population growth (in %) of Barbados in 1968 to that in 1974?
Keep it short and to the point. 0.37. What is the ratio of the Population growth (in %) in Comoros in 1968 to that in 1974?
Keep it short and to the point. 0.95. What is the ratio of the Population growth (in %) of El Salvador in 1968 to that in 1974?
Offer a very short reply. 0.83. What is the ratio of the Population growth (in %) in Hungary in 1968 to that in 1974?
Ensure brevity in your answer.  0.96. What is the ratio of the Population growth (in %) of Barbados in 1969 to that in 1970?
Make the answer very short. 0.73. What is the ratio of the Population growth (in %) in Comoros in 1969 to that in 1970?
Your answer should be compact. 1.02. What is the ratio of the Population growth (in %) in El Salvador in 1969 to that in 1970?
Your answer should be compact. 1.01. What is the ratio of the Population growth (in %) in Hungary in 1969 to that in 1970?
Your answer should be very brief. 1.03. What is the ratio of the Population growth (in %) of Barbados in 1969 to that in 1971?
Keep it short and to the point. 0.46. What is the ratio of the Population growth (in %) of Comoros in 1969 to that in 1971?
Offer a very short reply. 1.04. What is the ratio of the Population growth (in %) of El Salvador in 1969 to that in 1971?
Your answer should be very brief. 1.03. What is the ratio of the Population growth (in %) in Hungary in 1969 to that in 1971?
Provide a short and direct response. 1.12. What is the ratio of the Population growth (in %) in Barbados in 1969 to that in 1972?
Offer a very short reply. 0.43. What is the ratio of the Population growth (in %) of Comoros in 1969 to that in 1972?
Make the answer very short. 1.06. What is the ratio of the Population growth (in %) in El Salvador in 1969 to that in 1972?
Your response must be concise. 0.78. What is the ratio of the Population growth (in %) in Hungary in 1969 to that in 1972?
Offer a terse response. 1.12. What is the ratio of the Population growth (in %) of Barbados in 1969 to that in 1973?
Ensure brevity in your answer.  0.41. What is the ratio of the Population growth (in %) of Comoros in 1969 to that in 1973?
Your response must be concise. 1.03. What is the ratio of the Population growth (in %) in El Salvador in 1969 to that in 1973?
Give a very brief answer. 0.79. What is the ratio of the Population growth (in %) of Hungary in 1969 to that in 1973?
Your response must be concise. 1.1. What is the ratio of the Population growth (in %) of Barbados in 1969 to that in 1974?
Make the answer very short. 0.41. What is the ratio of the Population growth (in %) of Comoros in 1969 to that in 1974?
Your answer should be very brief. 0.95. What is the ratio of the Population growth (in %) of El Salvador in 1969 to that in 1974?
Provide a short and direct response. 0.81. What is the ratio of the Population growth (in %) of Hungary in 1969 to that in 1974?
Your response must be concise. 0.99. What is the ratio of the Population growth (in %) in Barbados in 1970 to that in 1971?
Provide a short and direct response. 0.63. What is the ratio of the Population growth (in %) in Comoros in 1970 to that in 1971?
Your answer should be very brief. 1.03. What is the ratio of the Population growth (in %) in El Salvador in 1970 to that in 1971?
Give a very brief answer. 1.01. What is the ratio of the Population growth (in %) of Hungary in 1970 to that in 1971?
Provide a succinct answer. 1.09. What is the ratio of the Population growth (in %) of Barbados in 1970 to that in 1972?
Keep it short and to the point. 0.59. What is the ratio of the Population growth (in %) of Comoros in 1970 to that in 1972?
Offer a terse response. 1.04. What is the ratio of the Population growth (in %) in El Salvador in 1970 to that in 1972?
Keep it short and to the point. 0.76. What is the ratio of the Population growth (in %) of Barbados in 1970 to that in 1973?
Offer a terse response. 0.56. What is the ratio of the Population growth (in %) in Comoros in 1970 to that in 1973?
Offer a terse response. 1.01. What is the ratio of the Population growth (in %) of El Salvador in 1970 to that in 1973?
Provide a succinct answer. 0.78. What is the ratio of the Population growth (in %) of Hungary in 1970 to that in 1973?
Offer a very short reply. 1.07. What is the ratio of the Population growth (in %) of Barbados in 1970 to that in 1974?
Your answer should be compact. 0.56. What is the ratio of the Population growth (in %) of Comoros in 1970 to that in 1974?
Ensure brevity in your answer.  0.93. What is the ratio of the Population growth (in %) of El Salvador in 1970 to that in 1974?
Keep it short and to the point. 0.8. What is the ratio of the Population growth (in %) of Hungary in 1970 to that in 1974?
Provide a succinct answer. 0.96. What is the ratio of the Population growth (in %) in Barbados in 1971 to that in 1972?
Offer a terse response. 0.93. What is the ratio of the Population growth (in %) of Comoros in 1971 to that in 1972?
Offer a terse response. 1.01. What is the ratio of the Population growth (in %) of El Salvador in 1971 to that in 1972?
Keep it short and to the point. 0.75. What is the ratio of the Population growth (in %) in Hungary in 1971 to that in 1972?
Provide a short and direct response. 0.99. What is the ratio of the Population growth (in %) of Barbados in 1971 to that in 1973?
Ensure brevity in your answer.  0.89. What is the ratio of the Population growth (in %) of Comoros in 1971 to that in 1973?
Offer a very short reply. 0.98. What is the ratio of the Population growth (in %) of El Salvador in 1971 to that in 1973?
Make the answer very short. 0.77. What is the ratio of the Population growth (in %) of Hungary in 1971 to that in 1973?
Keep it short and to the point. 0.98. What is the ratio of the Population growth (in %) of Barbados in 1971 to that in 1974?
Offer a very short reply. 0.89. What is the ratio of the Population growth (in %) of Comoros in 1971 to that in 1974?
Your answer should be very brief. 0.91. What is the ratio of the Population growth (in %) in El Salvador in 1971 to that in 1974?
Your answer should be compact. 0.79. What is the ratio of the Population growth (in %) of Hungary in 1971 to that in 1974?
Your answer should be very brief. 0.88. What is the ratio of the Population growth (in %) of Barbados in 1972 to that in 1973?
Provide a short and direct response. 0.96. What is the ratio of the Population growth (in %) of Comoros in 1972 to that in 1973?
Your response must be concise. 0.97. What is the ratio of the Population growth (in %) in El Salvador in 1972 to that in 1973?
Your answer should be compact. 1.02. What is the ratio of the Population growth (in %) of Hungary in 1972 to that in 1973?
Make the answer very short. 0.99. What is the ratio of the Population growth (in %) in Barbados in 1972 to that in 1974?
Keep it short and to the point. 0.96. What is the ratio of the Population growth (in %) of Comoros in 1972 to that in 1974?
Offer a terse response. 0.89. What is the ratio of the Population growth (in %) in El Salvador in 1972 to that in 1974?
Offer a terse response. 1.05. What is the ratio of the Population growth (in %) in Hungary in 1972 to that in 1974?
Ensure brevity in your answer.  0.88. What is the ratio of the Population growth (in %) of Comoros in 1973 to that in 1974?
Offer a very short reply. 0.92. What is the ratio of the Population growth (in %) in El Salvador in 1973 to that in 1974?
Keep it short and to the point. 1.03. What is the ratio of the Population growth (in %) in Hungary in 1973 to that in 1974?
Provide a succinct answer. 0.9. What is the difference between the highest and the second highest Population growth (in %) in Barbados?
Provide a succinct answer. 0.01. What is the difference between the highest and the second highest Population growth (in %) of Comoros?
Ensure brevity in your answer.  0.21. What is the difference between the highest and the second highest Population growth (in %) in El Salvador?
Give a very brief answer. 0.09. What is the difference between the highest and the second highest Population growth (in %) in Hungary?
Offer a terse response. 0.02. What is the difference between the highest and the lowest Population growth (in %) in Barbados?
Make the answer very short. 0.77. What is the difference between the highest and the lowest Population growth (in %) in Comoros?
Make the answer very short. 0.46. What is the difference between the highest and the lowest Population growth (in %) of El Salvador?
Your answer should be compact. 0.94. What is the difference between the highest and the lowest Population growth (in %) in Hungary?
Your response must be concise. 0.14. 